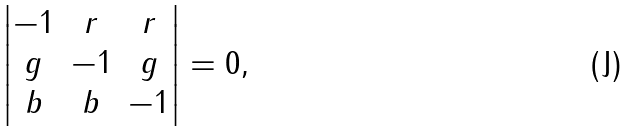Convert formula to latex. <formula><loc_0><loc_0><loc_500><loc_500>\begin{vmatrix} - 1 & r & r \\ g & - 1 & g \\ b & b & - 1 \end{vmatrix} = 0 ,</formula> 